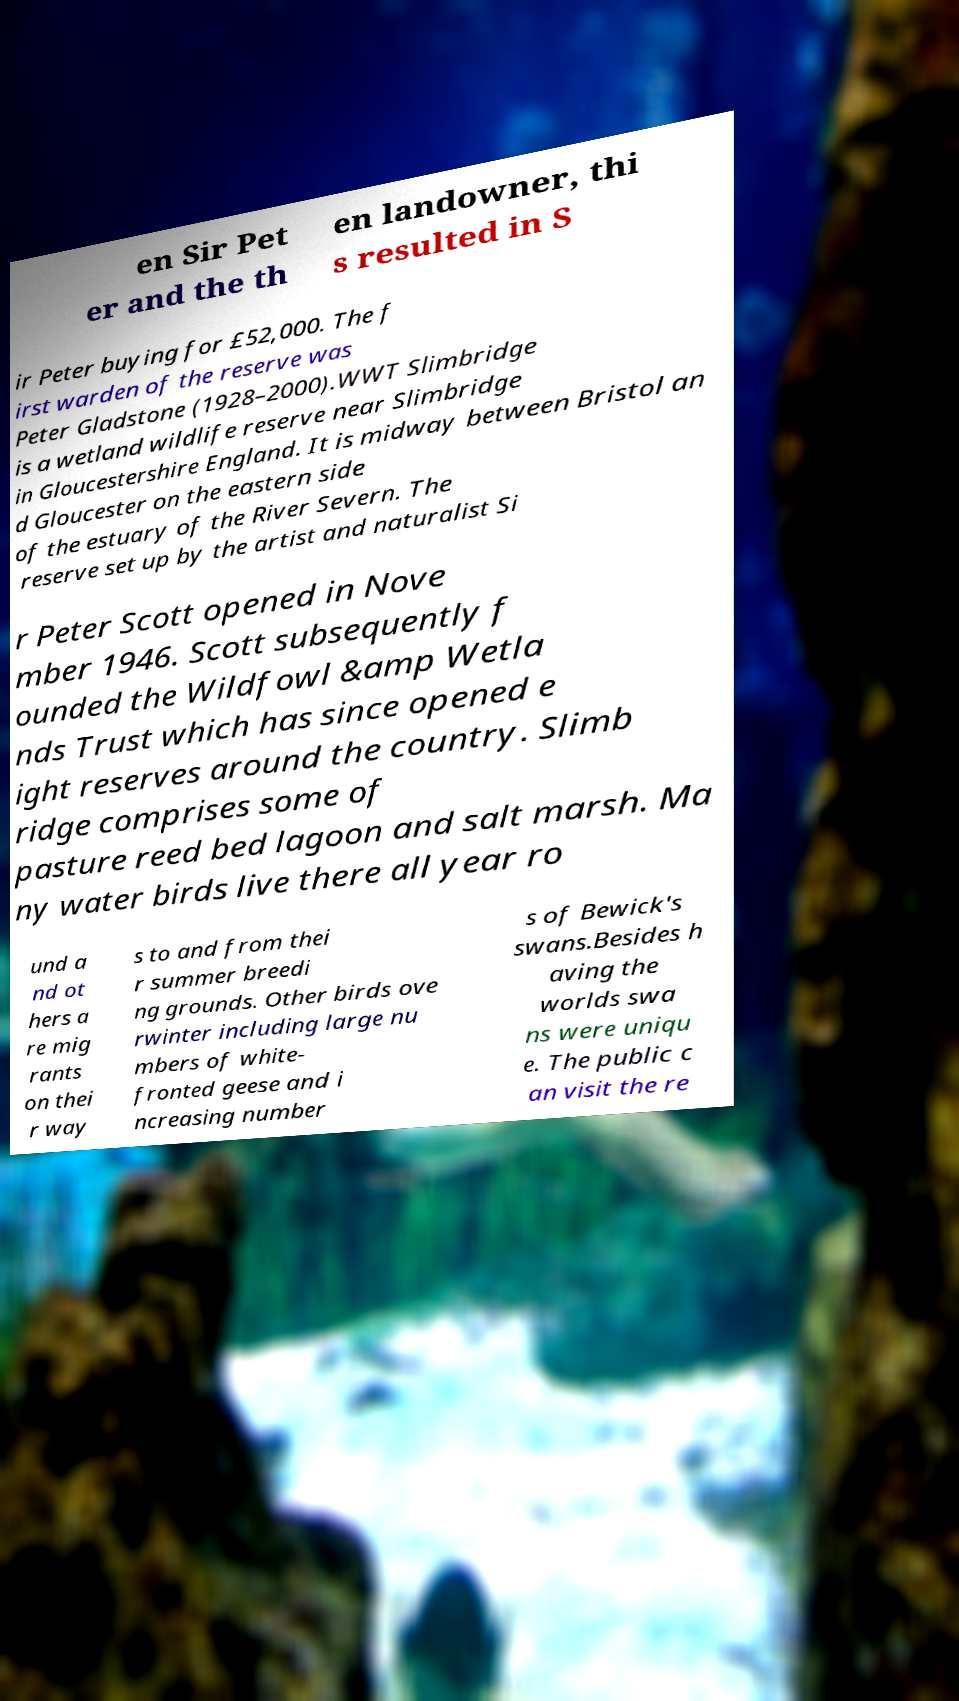Please read and relay the text visible in this image. What does it say? en Sir Pet er and the th en landowner, thi s resulted in S ir Peter buying for £52,000. The f irst warden of the reserve was Peter Gladstone (1928–2000).WWT Slimbridge is a wetland wildlife reserve near Slimbridge in Gloucestershire England. It is midway between Bristol an d Gloucester on the eastern side of the estuary of the River Severn. The reserve set up by the artist and naturalist Si r Peter Scott opened in Nove mber 1946. Scott subsequently f ounded the Wildfowl &amp Wetla nds Trust which has since opened e ight reserves around the country. Slimb ridge comprises some of pasture reed bed lagoon and salt marsh. Ma ny water birds live there all year ro und a nd ot hers a re mig rants on thei r way s to and from thei r summer breedi ng grounds. Other birds ove rwinter including large nu mbers of white- fronted geese and i ncreasing number s of Bewick's swans.Besides h aving the worlds swa ns were uniqu e. The public c an visit the re 